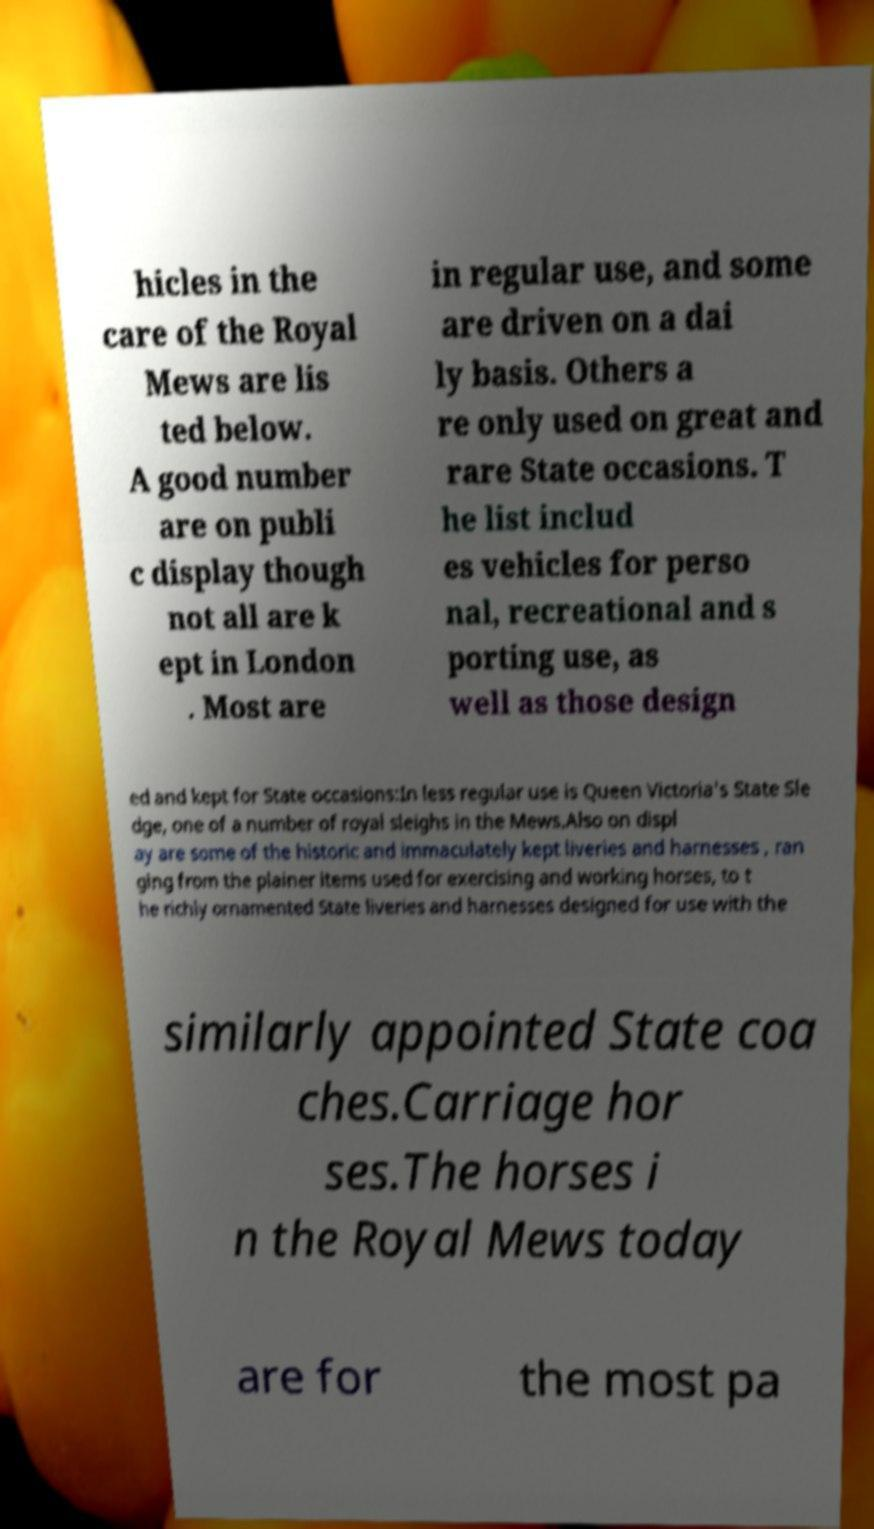There's text embedded in this image that I need extracted. Can you transcribe it verbatim? hicles in the care of the Royal Mews are lis ted below. A good number are on publi c display though not all are k ept in London . Most are in regular use, and some are driven on a dai ly basis. Others a re only used on great and rare State occasions. T he list includ es vehicles for perso nal, recreational and s porting use, as well as those design ed and kept for State occasions:In less regular use is Queen Victoria's State Sle dge, one of a number of royal sleighs in the Mews.Also on displ ay are some of the historic and immaculately kept liveries and harnesses , ran ging from the plainer items used for exercising and working horses, to t he richly ornamented State liveries and harnesses designed for use with the similarly appointed State coa ches.Carriage hor ses.The horses i n the Royal Mews today are for the most pa 